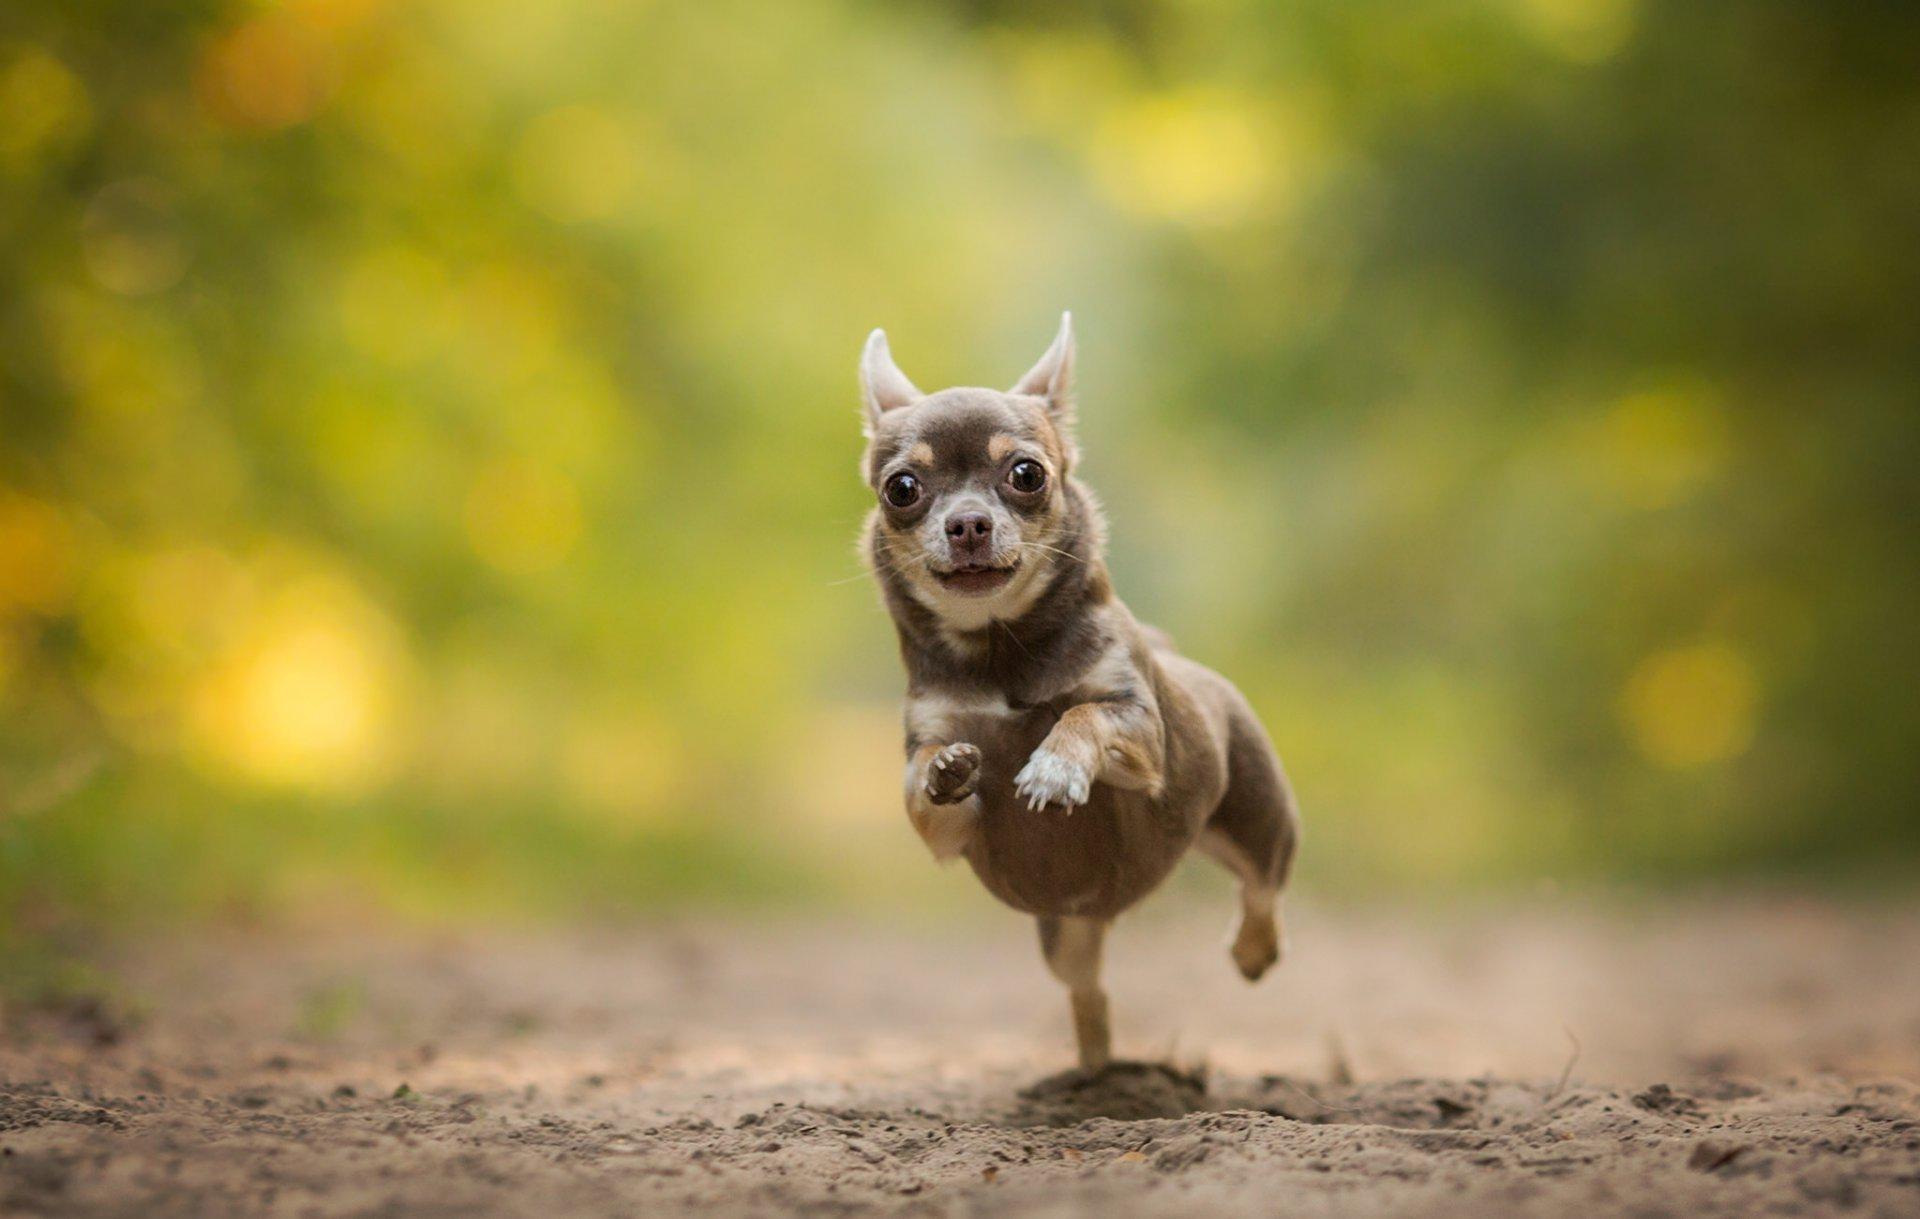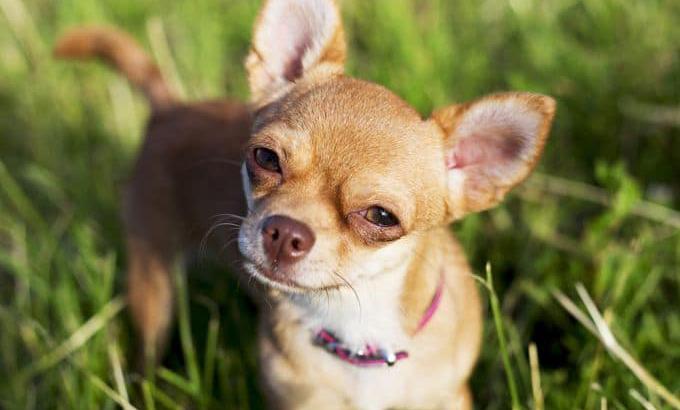The first image is the image on the left, the second image is the image on the right. Given the left and right images, does the statement "Both dogs are looking toward the camera." hold true? Answer yes or no. Yes. 